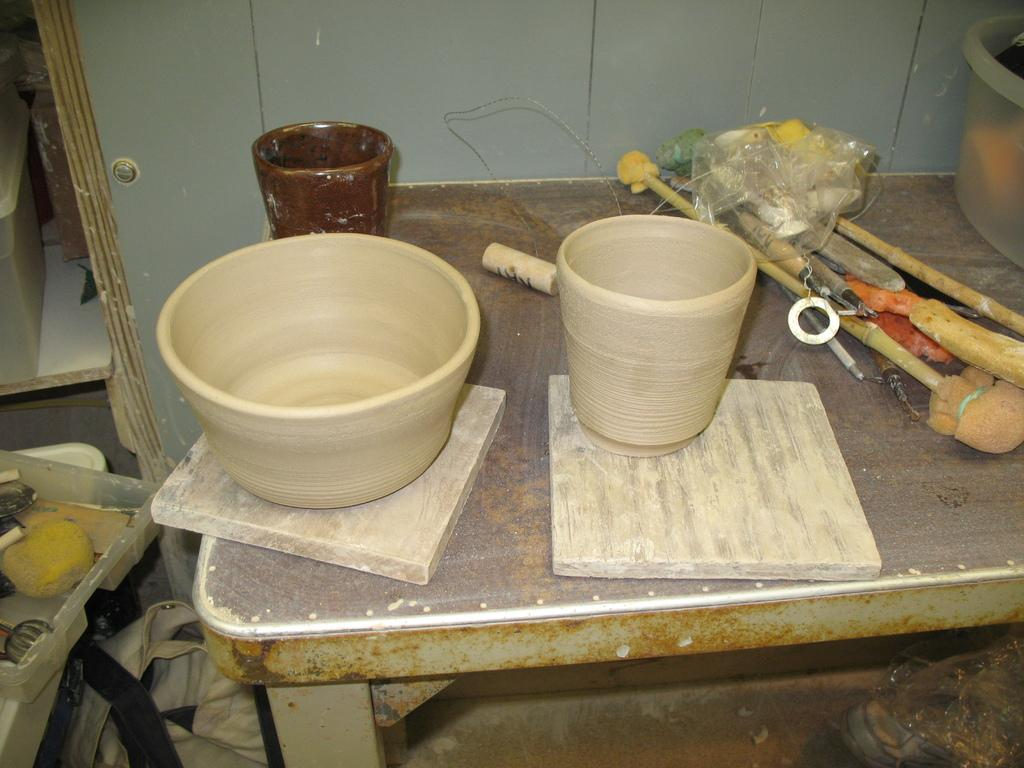What type of furniture is present in the image? There is a table in the image. What is placed on the table? There are bowls on the table. What are the bowls resting on? The bowls are on wooden pieces. What objects are beside the bowls? There are brushes beside the bowls. What can be seen on the wall in the image? There is a mirror on the left side wall. What title is written on the mirror in the image? There is no title written on the mirror in the image. Can you see a cat in the image? There is no cat present in the image. 